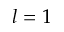<formula> <loc_0><loc_0><loc_500><loc_500>l = 1</formula> 